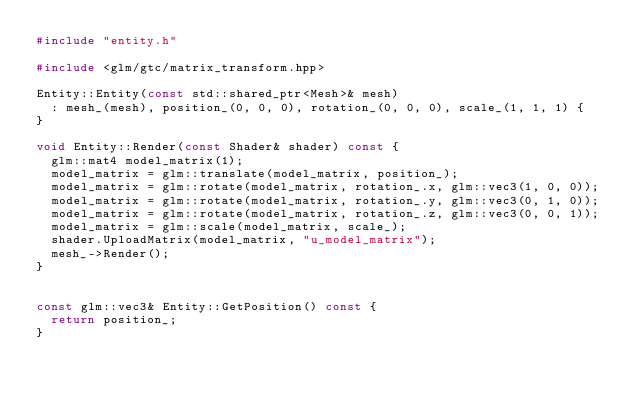Convert code to text. <code><loc_0><loc_0><loc_500><loc_500><_C++_>#include "entity.h"

#include <glm/gtc/matrix_transform.hpp>

Entity::Entity(const std::shared_ptr<Mesh>& mesh) 
  : mesh_(mesh), position_(0, 0, 0), rotation_(0, 0, 0), scale_(1, 1, 1) {
}

void Entity::Render(const Shader& shader) const {
  glm::mat4 model_matrix(1);
  model_matrix = glm::translate(model_matrix, position_);
  model_matrix = glm::rotate(model_matrix, rotation_.x, glm::vec3(1, 0, 0));
  model_matrix = glm::rotate(model_matrix, rotation_.y, glm::vec3(0, 1, 0));
  model_matrix = glm::rotate(model_matrix, rotation_.z, glm::vec3(0, 0, 1));
  model_matrix = glm::scale(model_matrix, scale_);
  shader.UploadMatrix(model_matrix, "u_model_matrix");
  mesh_->Render();
}


const glm::vec3& Entity::GetPosition() const {
  return position_;
}
</code> 